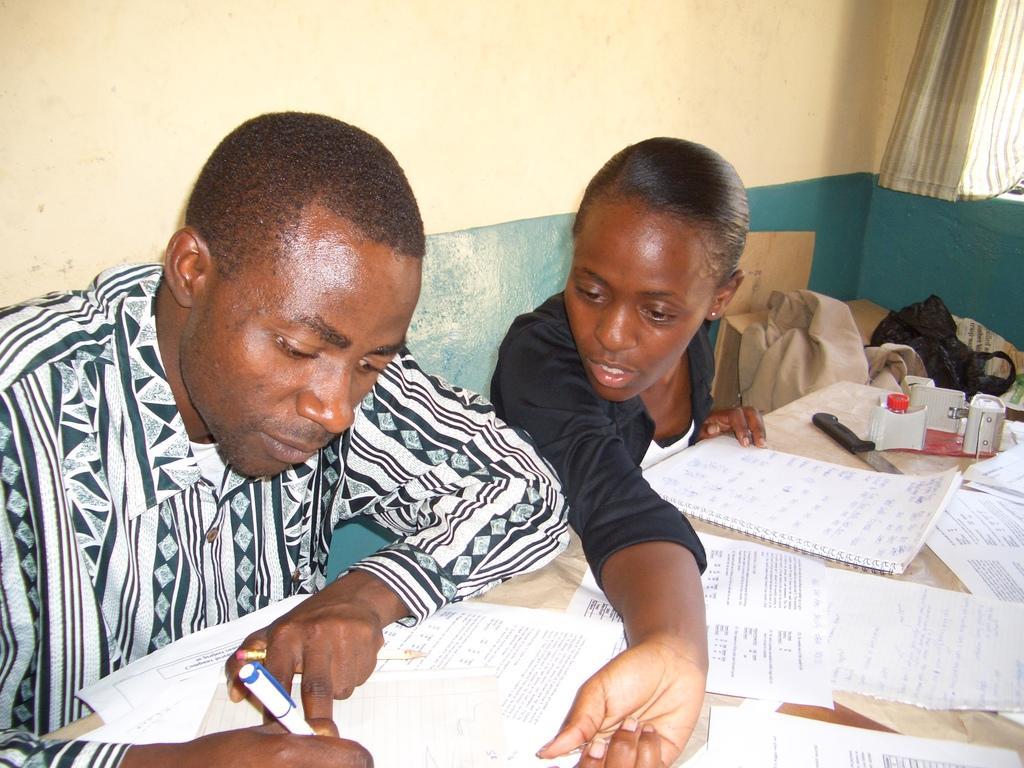Can you describe this image briefly? To the left corner of the image there is a man with a designer shirt. Beside him there is a lady with black dress is sitting. In front of them there is a table with papers, books and a few other items on it. Beside the lady to the right side there are few items. And to the top right corner of the image there is a curtain. And in the background there is a wall with white and green painting on it. 